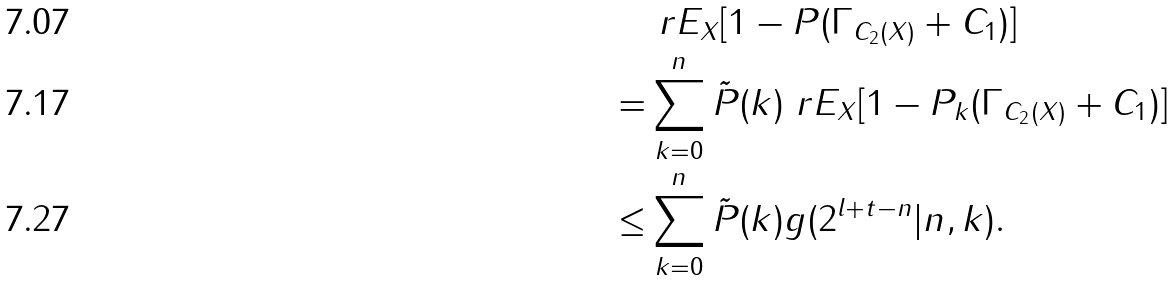<formula> <loc_0><loc_0><loc_500><loc_500>& \ r E _ { X } [ 1 - P ( \Gamma _ { C _ { 2 } ( X ) } + C _ { 1 } ) ] \\ = & \sum _ { k = 0 } ^ { n } \tilde { P } ( k ) \ r E _ { X } [ 1 - P _ { k } ( \Gamma _ { C _ { 2 } ( X ) } + C _ { 1 } ) ] \\ \leq & \sum _ { k = 0 } ^ { n } \tilde { P } ( k ) g ( 2 ^ { l + t - n } | n , k ) .</formula> 